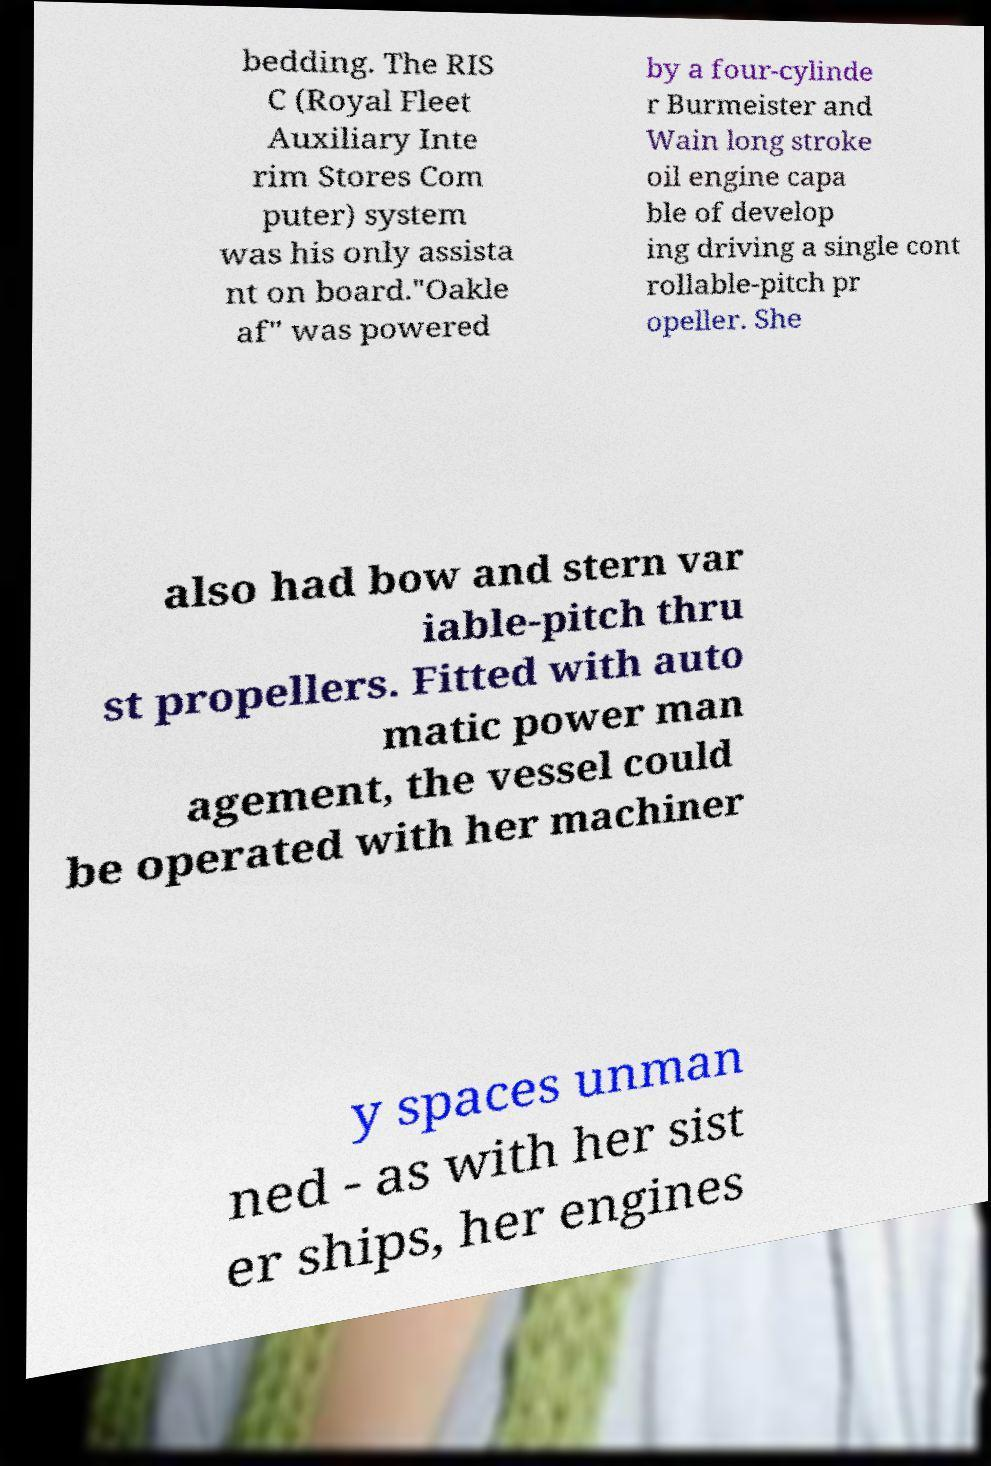For documentation purposes, I need the text within this image transcribed. Could you provide that? bedding. The RIS C (Royal Fleet Auxiliary Inte rim Stores Com puter) system was his only assista nt on board."Oakle af" was powered by a four-cylinde r Burmeister and Wain long stroke oil engine capa ble of develop ing driving a single cont rollable-pitch pr opeller. She also had bow and stern var iable-pitch thru st propellers. Fitted with auto matic power man agement, the vessel could be operated with her machiner y spaces unman ned - as with her sist er ships, her engines 